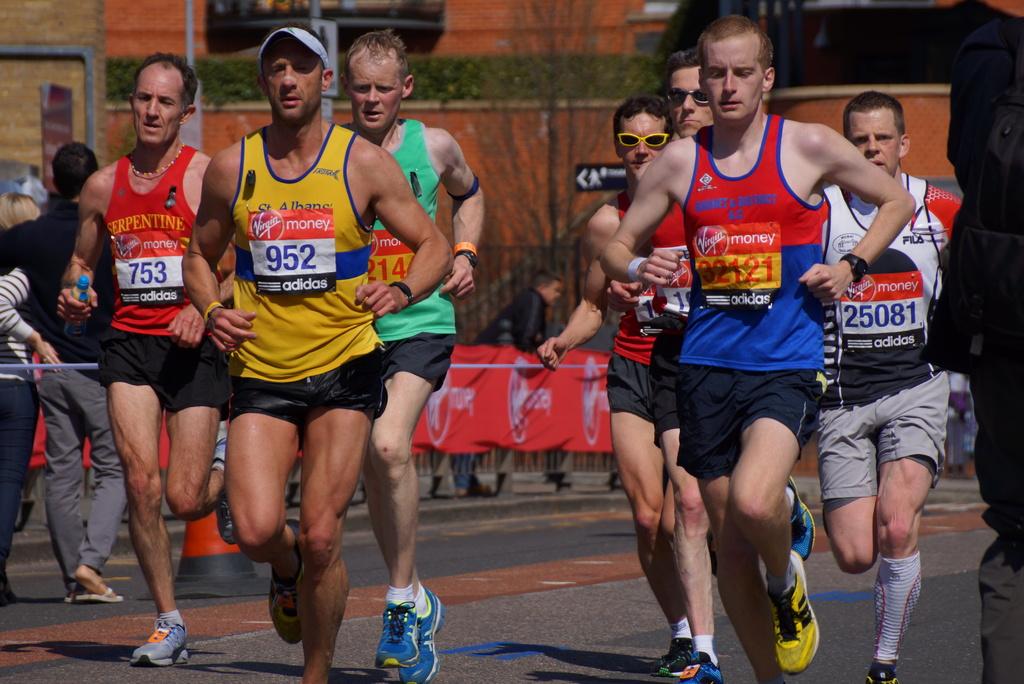What is the number of the racer with a yellow top?
Give a very brief answer. 952. 